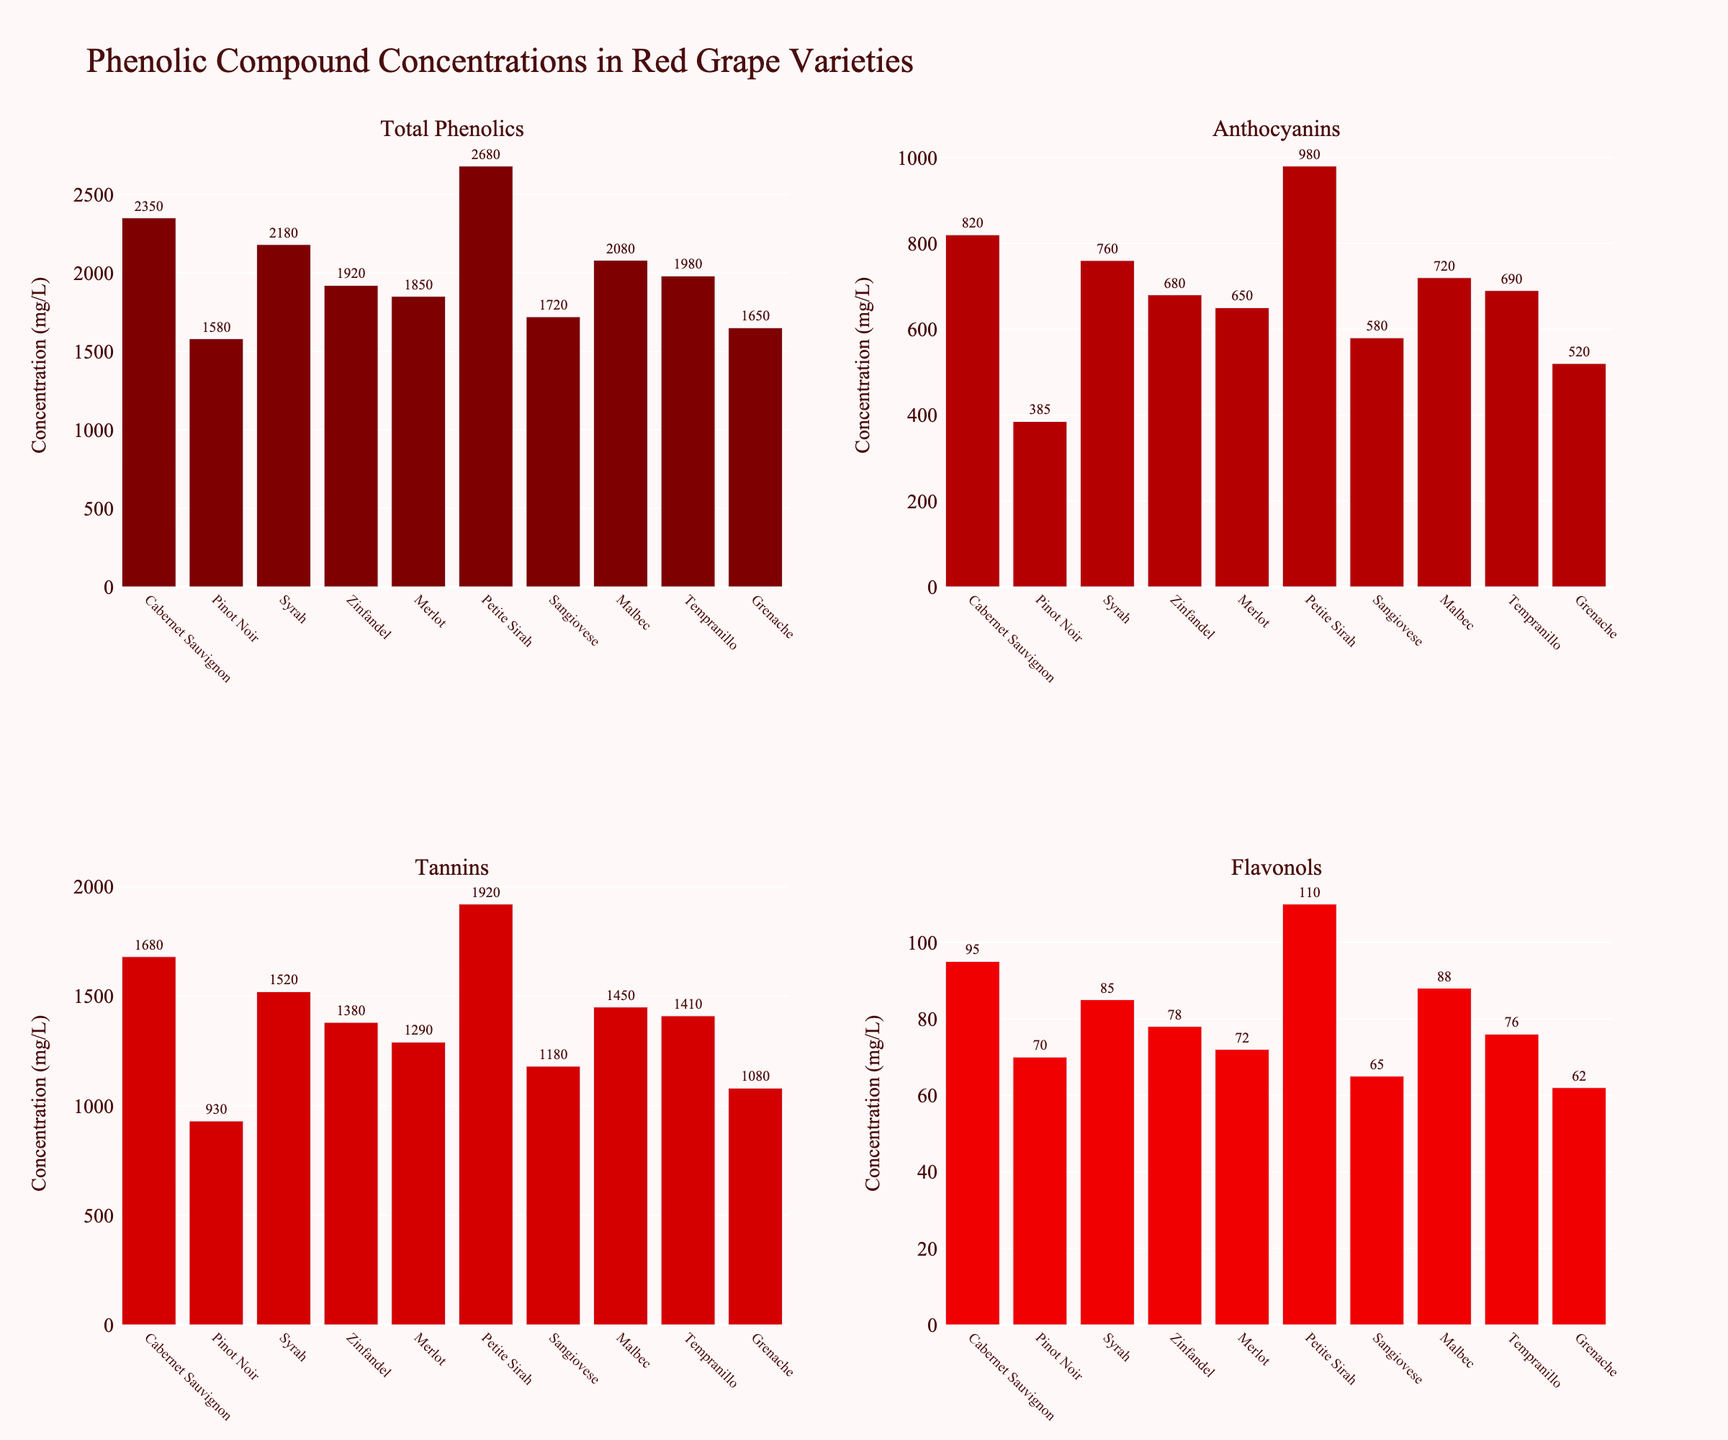What grape variety has the highest concentration of Total Phenolics? Locate the subplot titled 'Total Phenolics'. Identify which bar is the tallest. The tallest bar represents the variety with the highest concentration.
Answer: Petite Sirah Which grape variety has higher Tannins: Zinfandel or Pinot Noir? Locate the subplot titled 'Tannins'. Check the height of the bars for Zinfandel and Pinot Noir. Compare the heights to see which one is taller.
Answer: Zinfandel Which grape variety shows the lowest concentration of Flavonols? Locate the subplot titled 'Flavonols'. Identify the shortest bar, as it represents the variety with the lowest concentration.
Answer: Grenache Which grape variety has a higher concentration of Anthocyanins: Syrah or Malbec? Locate the subplot titled 'Anthocyanins'. Check the height of the bars for Syrah and Malbec. Compare the heights to see which one is taller.
Answer: Syrah What is the difference in Total Phenolics concentration between Cabernet Sauvignon and Sangiovese? Locate the subplot titled 'Total Phenolics'. Find the bars for Cabernet Sauvignon and Sangiovese and note their values (2350 mg/L and 1720 mg/L respectively). Subtract the smaller value from the larger one. 2350 - 1720 = 630
Answer: 630 Which grape variety has the highest combined concentration of Tannins and Flavonols? Locate the subplots titled 'Tannins' and 'Flavonols'. Add the values for Tannins and Flavonols for each variety and compare the sums. The variety with the highest sum has the highest combined concentration.
Answer: Petite Sirah Order the grape varieties from highest to lowest concentration of Total Phenolics. Locate the subplot titled ‘Total Phenolics’. List the values for each grape variety from highest to lowest.
Answer: Petite Sirah, Cabernet Sauvignon, Syrah, Malbec, Tempranillo, Zinfandel, Merlot, Sangiovese, Grenache, Pinot Noir Does Merlot have more or less Flavonols than Grenache? Locate the subplot titled 'Flavonols'. Check the height of the bars for Merlot and Grenache. Compare the heights to see which one is taller.
Answer: More Which grape variety has a higher concentration of Anthocyanins, Pinot Noir or Sangiovese? Locate the subplot titled 'Anthocyanins'. Check the height of the bars for Pinot Noir and Sangiovese. Compare the heights to see which one is taller.
Answer: Sangiovese 